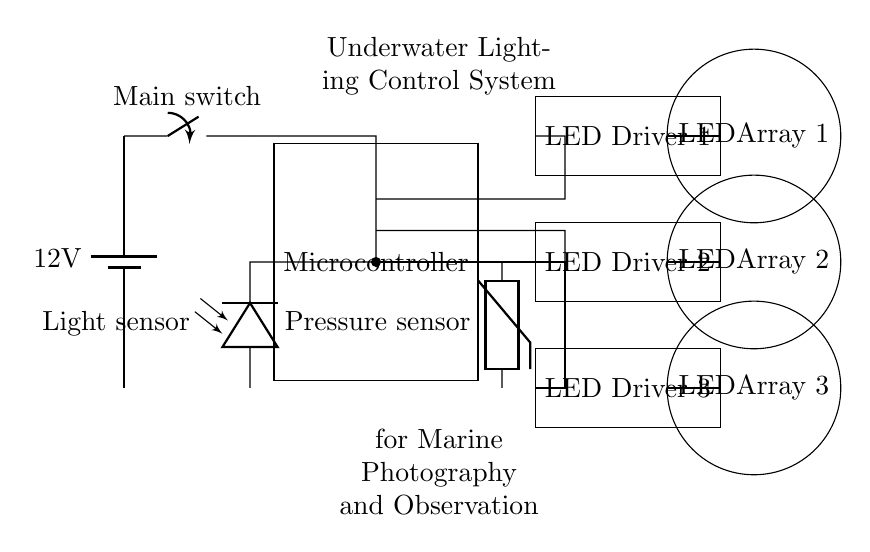What is the main power source voltage? The main power source in the circuit is a battery marked with a voltage of twelve volts, indicated in the diagram where the power supply is shown.
Answer: twelve volts How many LED drivers are present in this circuit? Upon examining the circuit diagram, there are three distinct LED drivers represented by rectangles labeled LED Driver 1, LED Driver 2, and LED Driver 3.
Answer: three Which sensor is used to detect light? The light sensor is labeled as a photodiode in the circuit diagram, clearly indicating its role in detecting light levels for control purposes.
Answer: photodiode What is the function of the microcontroller in this circuit? The microcontroller is responsible for processing inputs from the light and pressure sensors to control the LED drivers based on the conditions detected. This is evident as the microcontroller connects directly to the sensors and the LED drivers in the circuit.
Answer: processing inputs What types of sensors are included in this system? The circuit features two types of sensors: a photodiode for light detection and a thermistor for pressure measurement. These are clearly labeled in the diagram and connected to the microcontroller.
Answer: photodiode and thermistor How are the LED arrays powered? The LED arrays are powered through their respective LED drivers, which receive control signals from the microcontroller. The circuit shows connections from the microcontroller to the LED drivers, which then supply power to the LED arrays.
Answer: LED drivers 